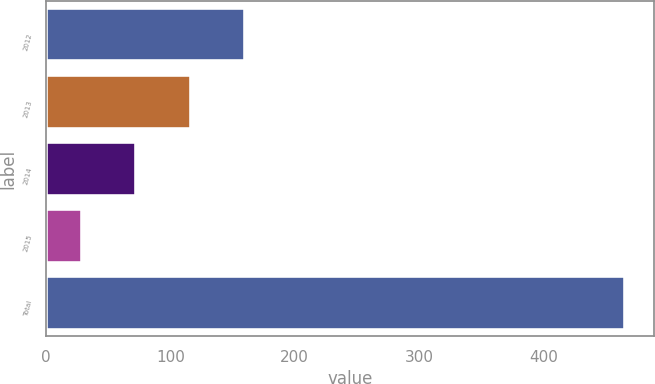Convert chart to OTSL. <chart><loc_0><loc_0><loc_500><loc_500><bar_chart><fcel>2012<fcel>2013<fcel>2014<fcel>2015<fcel>Total<nl><fcel>160.1<fcel>116.4<fcel>72.7<fcel>29<fcel>466<nl></chart> 